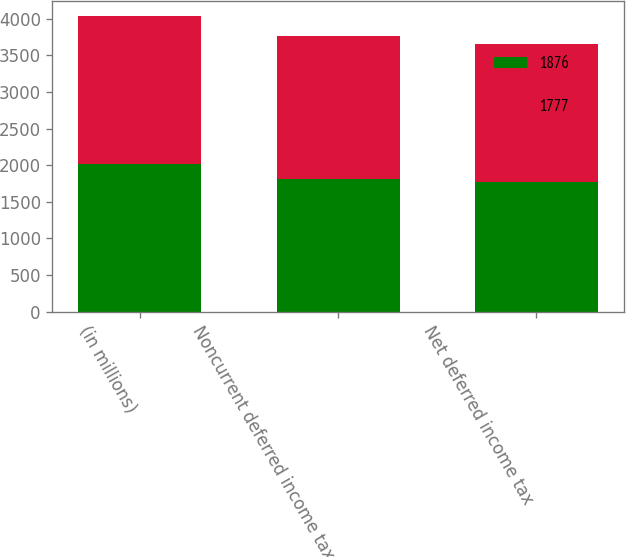<chart> <loc_0><loc_0><loc_500><loc_500><stacked_bar_chart><ecel><fcel>(in millions)<fcel>Noncurrent deferred income tax<fcel>Net deferred income tax<nl><fcel>1876<fcel>2018<fcel>1814<fcel>1777<nl><fcel>1777<fcel>2017<fcel>1949<fcel>1876<nl></chart> 